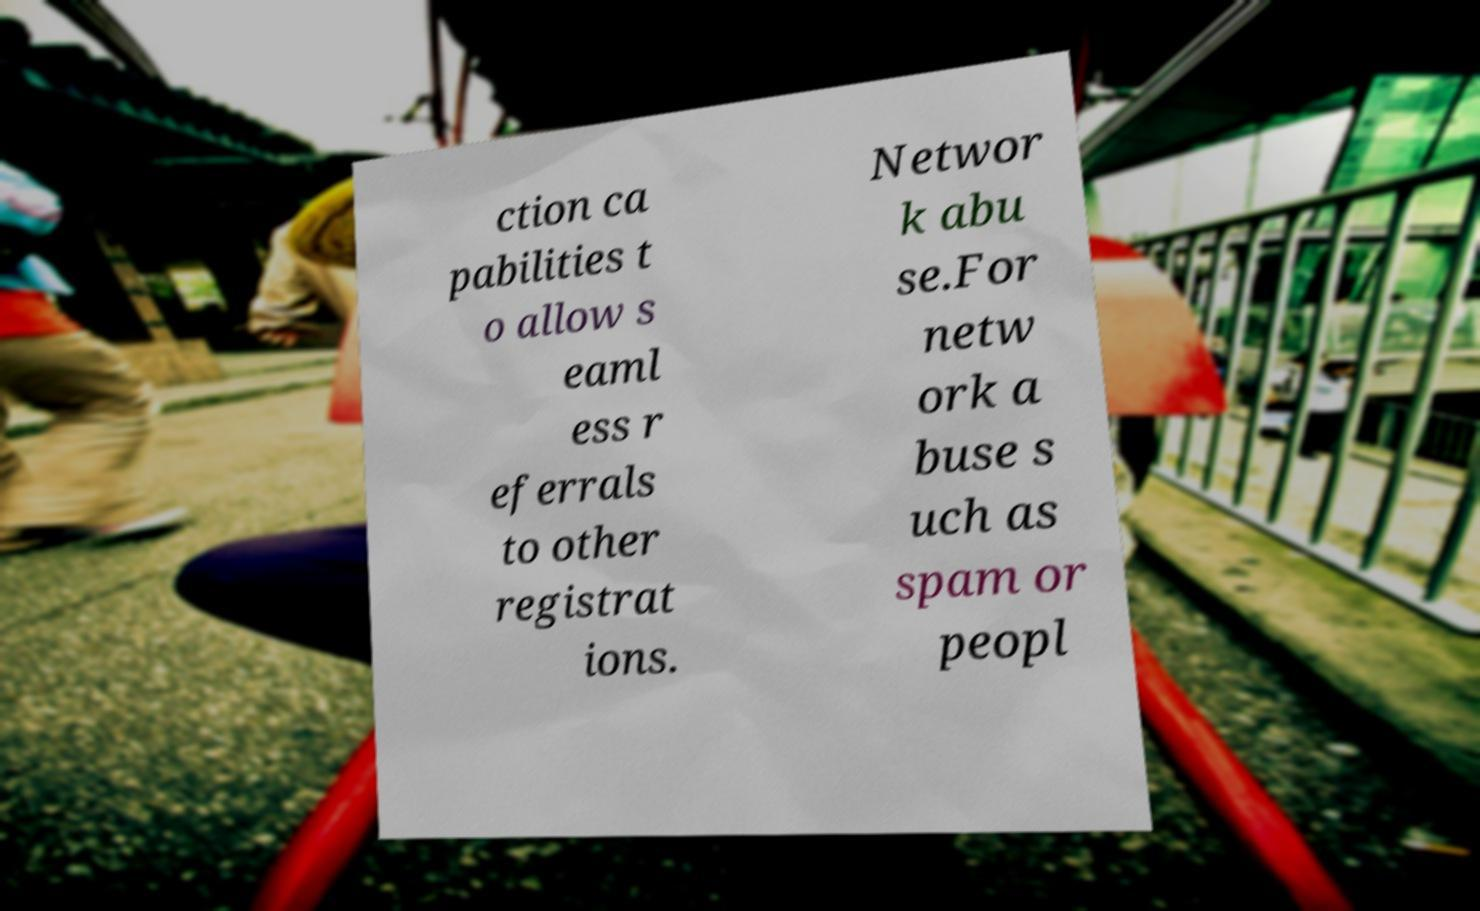Can you accurately transcribe the text from the provided image for me? ction ca pabilities t o allow s eaml ess r eferrals to other registrat ions. Networ k abu se.For netw ork a buse s uch as spam or peopl 